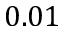<formula> <loc_0><loc_0><loc_500><loc_500>0 . 0 1</formula> 